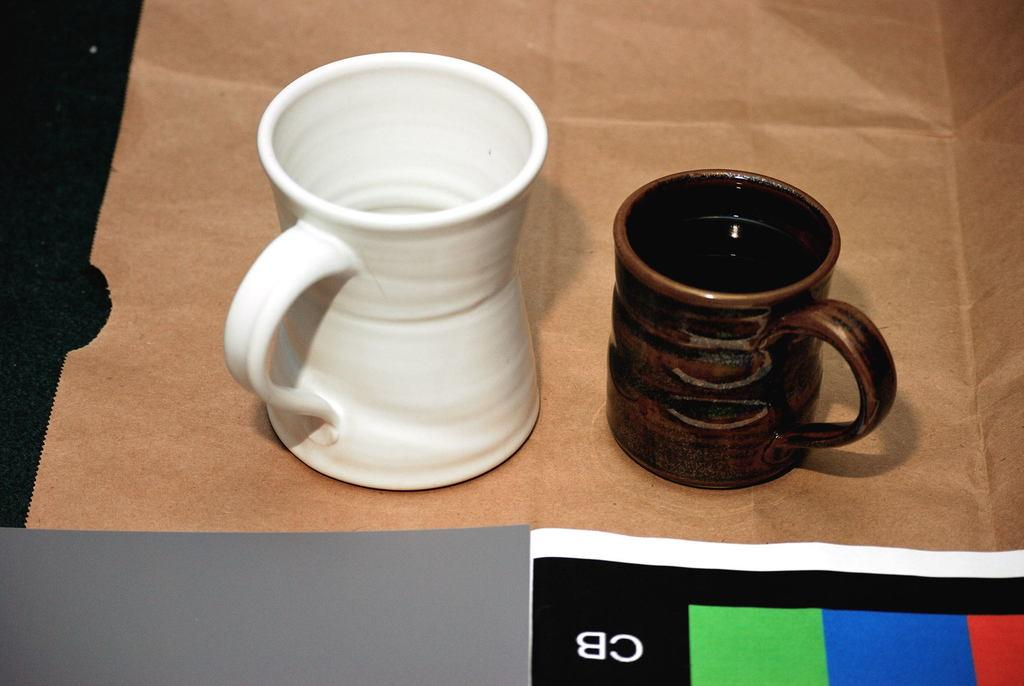<image>
Create a compact narrative representing the image presented. A black sheet with red, blue and green stripes with the letters CB is laying next to a white and a brown mug. 